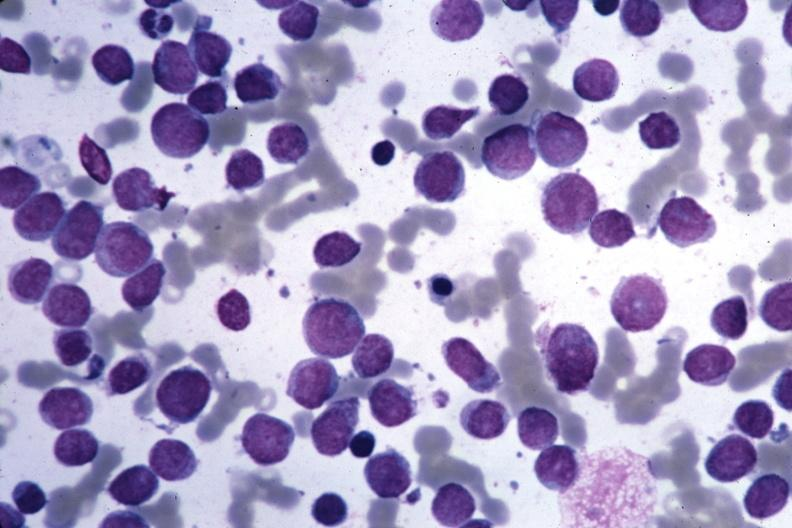what does this image show?
Answer the question using a single word or phrase. Wrights easily seen blastic cells 